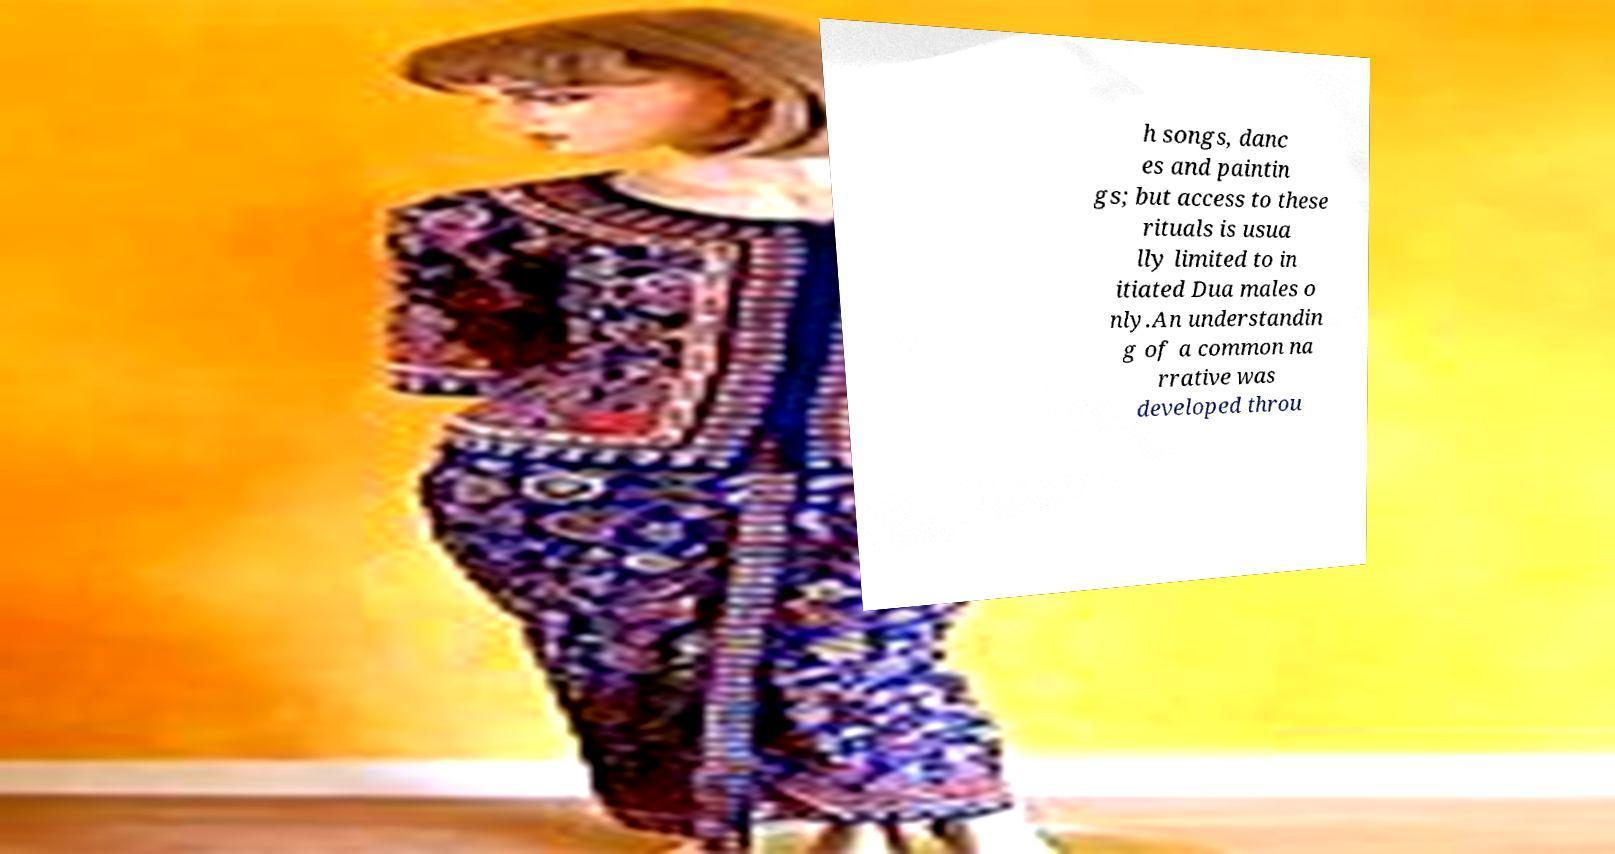There's text embedded in this image that I need extracted. Can you transcribe it verbatim? h songs, danc es and paintin gs; but access to these rituals is usua lly limited to in itiated Dua males o nly.An understandin g of a common na rrative was developed throu 